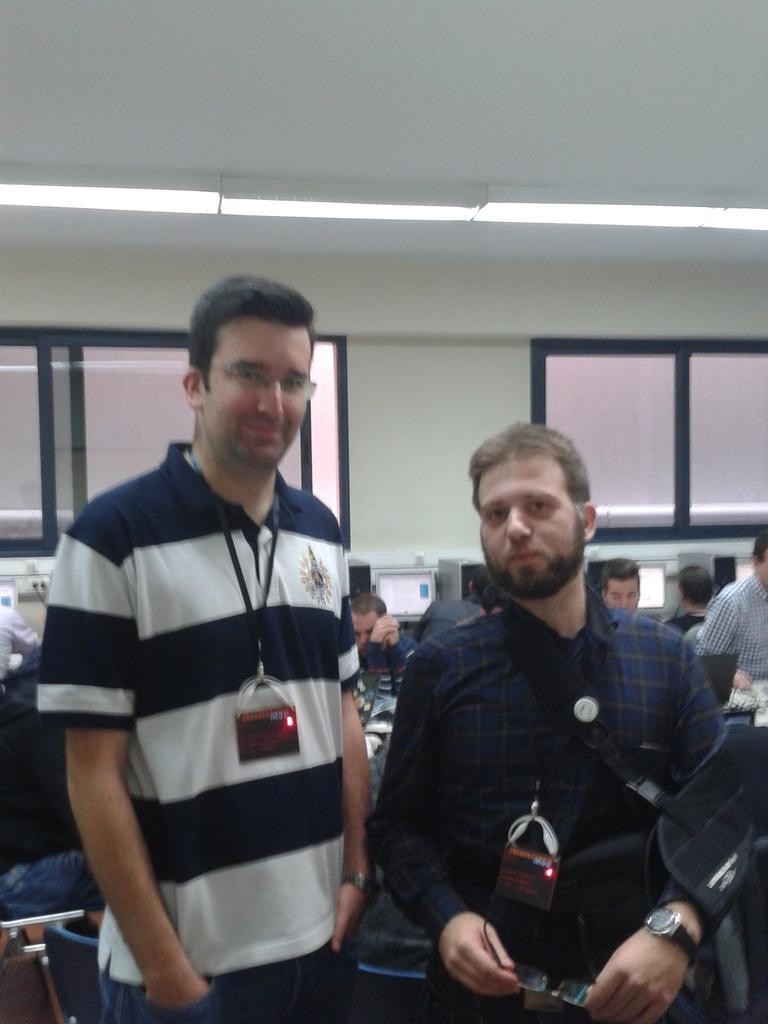In one or two sentences, can you explain what this image depicts? In the center of the image we can see women standing on the floor wearing a ID card. In the background we can see monitors, persons, windows, lights and wall. 